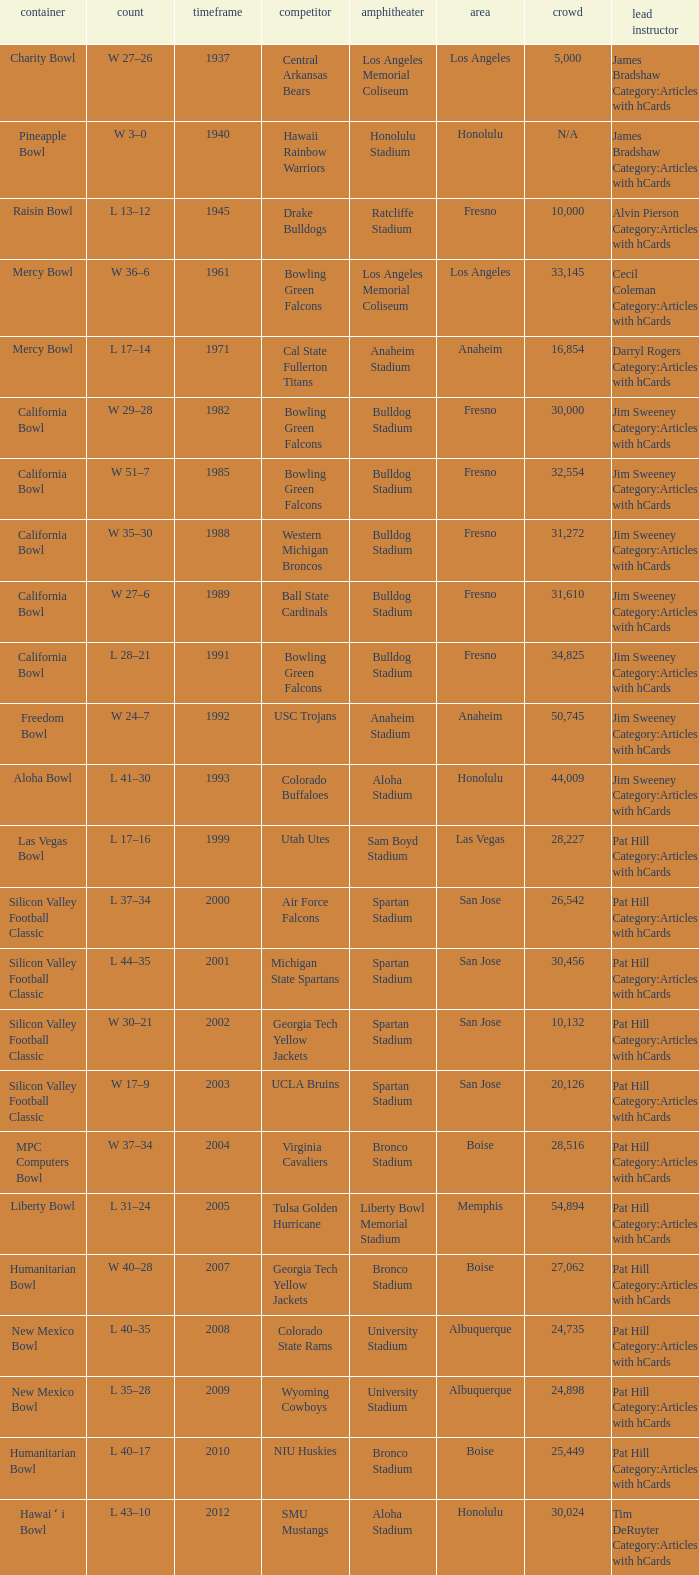What stadium had an opponent of Cal State Fullerton Titans? Anaheim Stadium. 